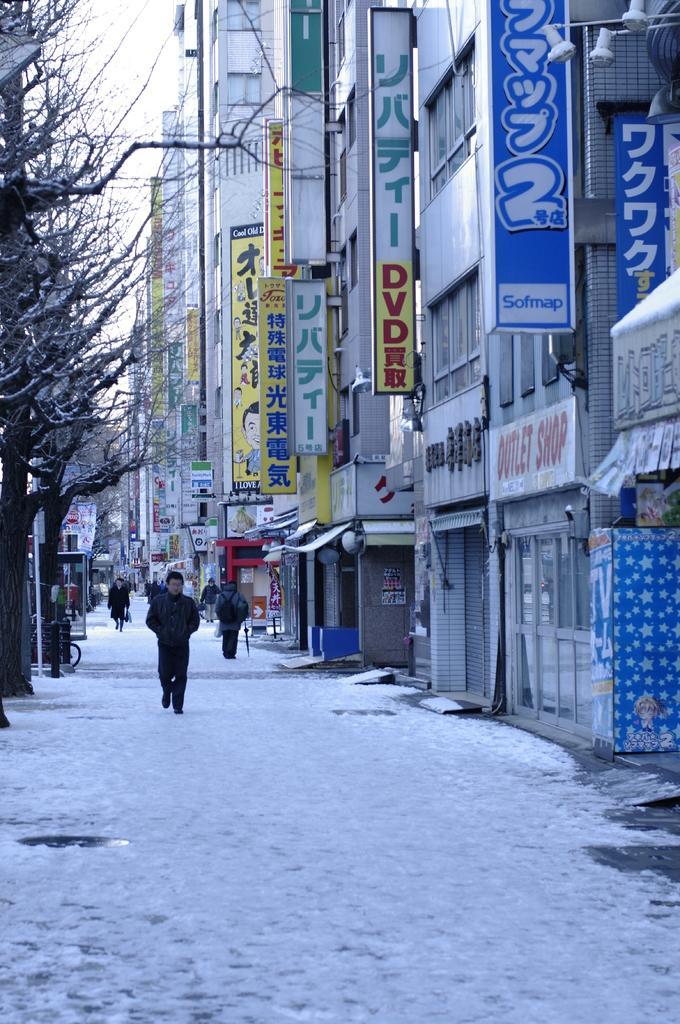In one or two sentences, can you explain what this image depicts? In the picture I can see people are walking on the road which is covered with snow. On the left side of the image I can see dry trees and a bicycle. On the right side of the image I can see buildings, boards and in the background of the image I can see the sky. 